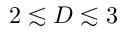<formula> <loc_0><loc_0><loc_500><loc_500>2 \lesssim D \lesssim 3</formula> 